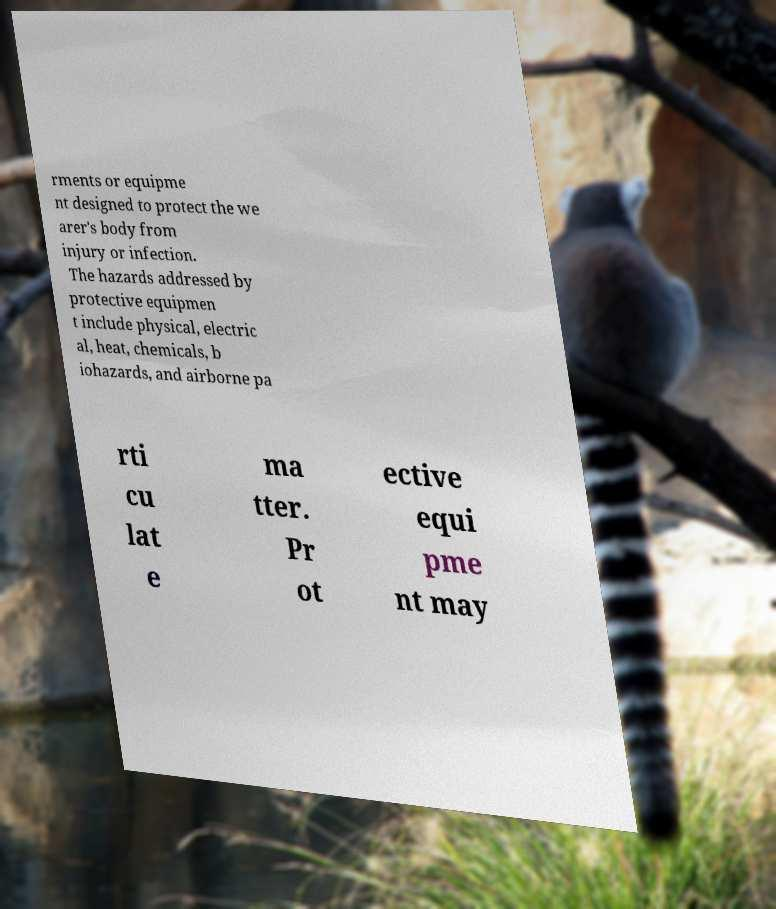Could you assist in decoding the text presented in this image and type it out clearly? rments or equipme nt designed to protect the we arer's body from injury or infection. The hazards addressed by protective equipmen t include physical, electric al, heat, chemicals, b iohazards, and airborne pa rti cu lat e ma tter. Pr ot ective equi pme nt may 